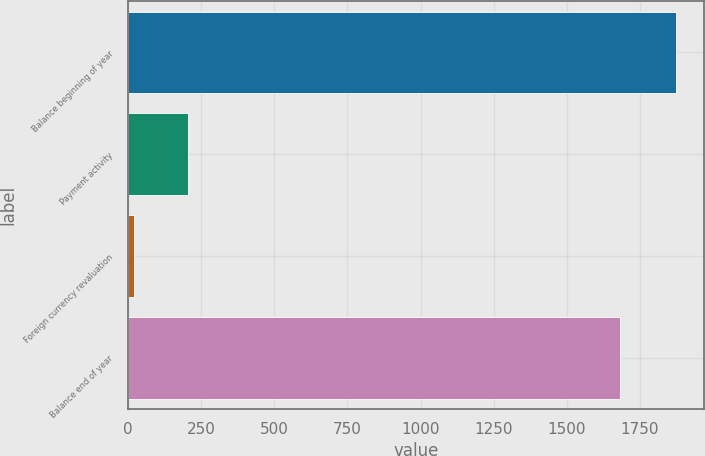Convert chart. <chart><loc_0><loc_0><loc_500><loc_500><bar_chart><fcel>Balance beginning of year<fcel>Payment activity<fcel>Foreign currency revaluation<fcel>Balance end of year<nl><fcel>1875<fcel>203.7<fcel>18<fcel>1683<nl></chart> 